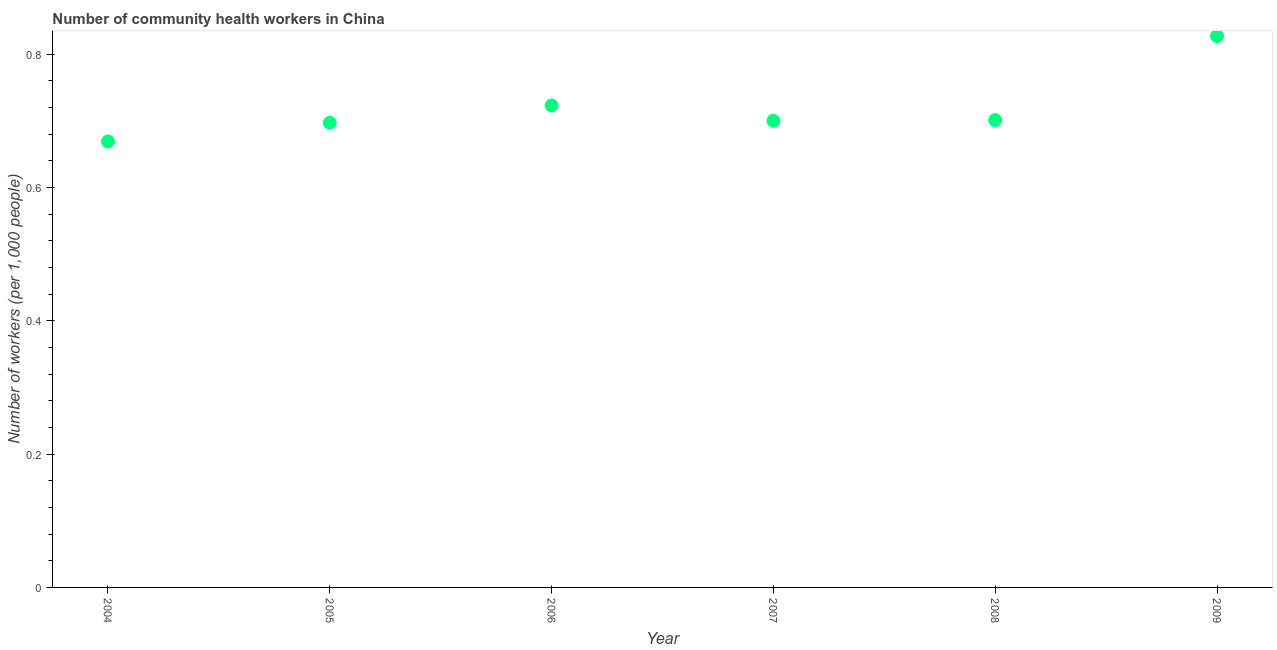What is the number of community health workers in 2005?
Make the answer very short. 0.7. Across all years, what is the maximum number of community health workers?
Ensure brevity in your answer.  0.83. Across all years, what is the minimum number of community health workers?
Ensure brevity in your answer.  0.67. In which year was the number of community health workers minimum?
Make the answer very short. 2004. What is the sum of the number of community health workers?
Provide a succinct answer. 4.32. What is the difference between the number of community health workers in 2005 and 2006?
Offer a terse response. -0.03. What is the average number of community health workers per year?
Offer a terse response. 0.72. What is the median number of community health workers?
Keep it short and to the point. 0.7. What is the ratio of the number of community health workers in 2008 to that in 2009?
Your response must be concise. 0.85. Is the number of community health workers in 2006 less than that in 2008?
Give a very brief answer. No. Is the difference between the number of community health workers in 2007 and 2008 greater than the difference between any two years?
Provide a short and direct response. No. What is the difference between the highest and the second highest number of community health workers?
Your response must be concise. 0.1. Is the sum of the number of community health workers in 2008 and 2009 greater than the maximum number of community health workers across all years?
Give a very brief answer. Yes. What is the difference between the highest and the lowest number of community health workers?
Provide a short and direct response. 0.16. In how many years, is the number of community health workers greater than the average number of community health workers taken over all years?
Your answer should be very brief. 2. What is the difference between two consecutive major ticks on the Y-axis?
Make the answer very short. 0.2. Does the graph contain grids?
Ensure brevity in your answer.  No. What is the title of the graph?
Provide a succinct answer. Number of community health workers in China. What is the label or title of the X-axis?
Provide a short and direct response. Year. What is the label or title of the Y-axis?
Provide a succinct answer. Number of workers (per 1,0 people). What is the Number of workers (per 1,000 people) in 2004?
Keep it short and to the point. 0.67. What is the Number of workers (per 1,000 people) in 2005?
Provide a succinct answer. 0.7. What is the Number of workers (per 1,000 people) in 2006?
Give a very brief answer. 0.72. What is the Number of workers (per 1,000 people) in 2007?
Your response must be concise. 0.7. What is the Number of workers (per 1,000 people) in 2008?
Your answer should be compact. 0.7. What is the Number of workers (per 1,000 people) in 2009?
Offer a terse response. 0.83. What is the difference between the Number of workers (per 1,000 people) in 2004 and 2005?
Make the answer very short. -0.03. What is the difference between the Number of workers (per 1,000 people) in 2004 and 2006?
Offer a very short reply. -0.05. What is the difference between the Number of workers (per 1,000 people) in 2004 and 2007?
Give a very brief answer. -0.03. What is the difference between the Number of workers (per 1,000 people) in 2004 and 2008?
Your answer should be compact. -0.03. What is the difference between the Number of workers (per 1,000 people) in 2004 and 2009?
Your response must be concise. -0.16. What is the difference between the Number of workers (per 1,000 people) in 2005 and 2006?
Provide a succinct answer. -0.03. What is the difference between the Number of workers (per 1,000 people) in 2005 and 2007?
Ensure brevity in your answer.  -0. What is the difference between the Number of workers (per 1,000 people) in 2005 and 2008?
Your answer should be very brief. -0. What is the difference between the Number of workers (per 1,000 people) in 2005 and 2009?
Your answer should be compact. -0.13. What is the difference between the Number of workers (per 1,000 people) in 2006 and 2007?
Your answer should be compact. 0.02. What is the difference between the Number of workers (per 1,000 people) in 2006 and 2008?
Provide a short and direct response. 0.02. What is the difference between the Number of workers (per 1,000 people) in 2006 and 2009?
Make the answer very short. -0.1. What is the difference between the Number of workers (per 1,000 people) in 2007 and 2008?
Ensure brevity in your answer.  -0. What is the difference between the Number of workers (per 1,000 people) in 2007 and 2009?
Give a very brief answer. -0.13. What is the difference between the Number of workers (per 1,000 people) in 2008 and 2009?
Your answer should be compact. -0.13. What is the ratio of the Number of workers (per 1,000 people) in 2004 to that in 2006?
Ensure brevity in your answer.  0.93. What is the ratio of the Number of workers (per 1,000 people) in 2004 to that in 2007?
Provide a succinct answer. 0.96. What is the ratio of the Number of workers (per 1,000 people) in 2004 to that in 2008?
Your answer should be very brief. 0.95. What is the ratio of the Number of workers (per 1,000 people) in 2004 to that in 2009?
Give a very brief answer. 0.81. What is the ratio of the Number of workers (per 1,000 people) in 2005 to that in 2006?
Make the answer very short. 0.96. What is the ratio of the Number of workers (per 1,000 people) in 2005 to that in 2009?
Ensure brevity in your answer.  0.84. What is the ratio of the Number of workers (per 1,000 people) in 2006 to that in 2007?
Provide a succinct answer. 1.03. What is the ratio of the Number of workers (per 1,000 people) in 2006 to that in 2008?
Your answer should be very brief. 1.03. What is the ratio of the Number of workers (per 1,000 people) in 2006 to that in 2009?
Provide a succinct answer. 0.87. What is the ratio of the Number of workers (per 1,000 people) in 2007 to that in 2008?
Your answer should be very brief. 1. What is the ratio of the Number of workers (per 1,000 people) in 2007 to that in 2009?
Provide a succinct answer. 0.85. What is the ratio of the Number of workers (per 1,000 people) in 2008 to that in 2009?
Make the answer very short. 0.85. 